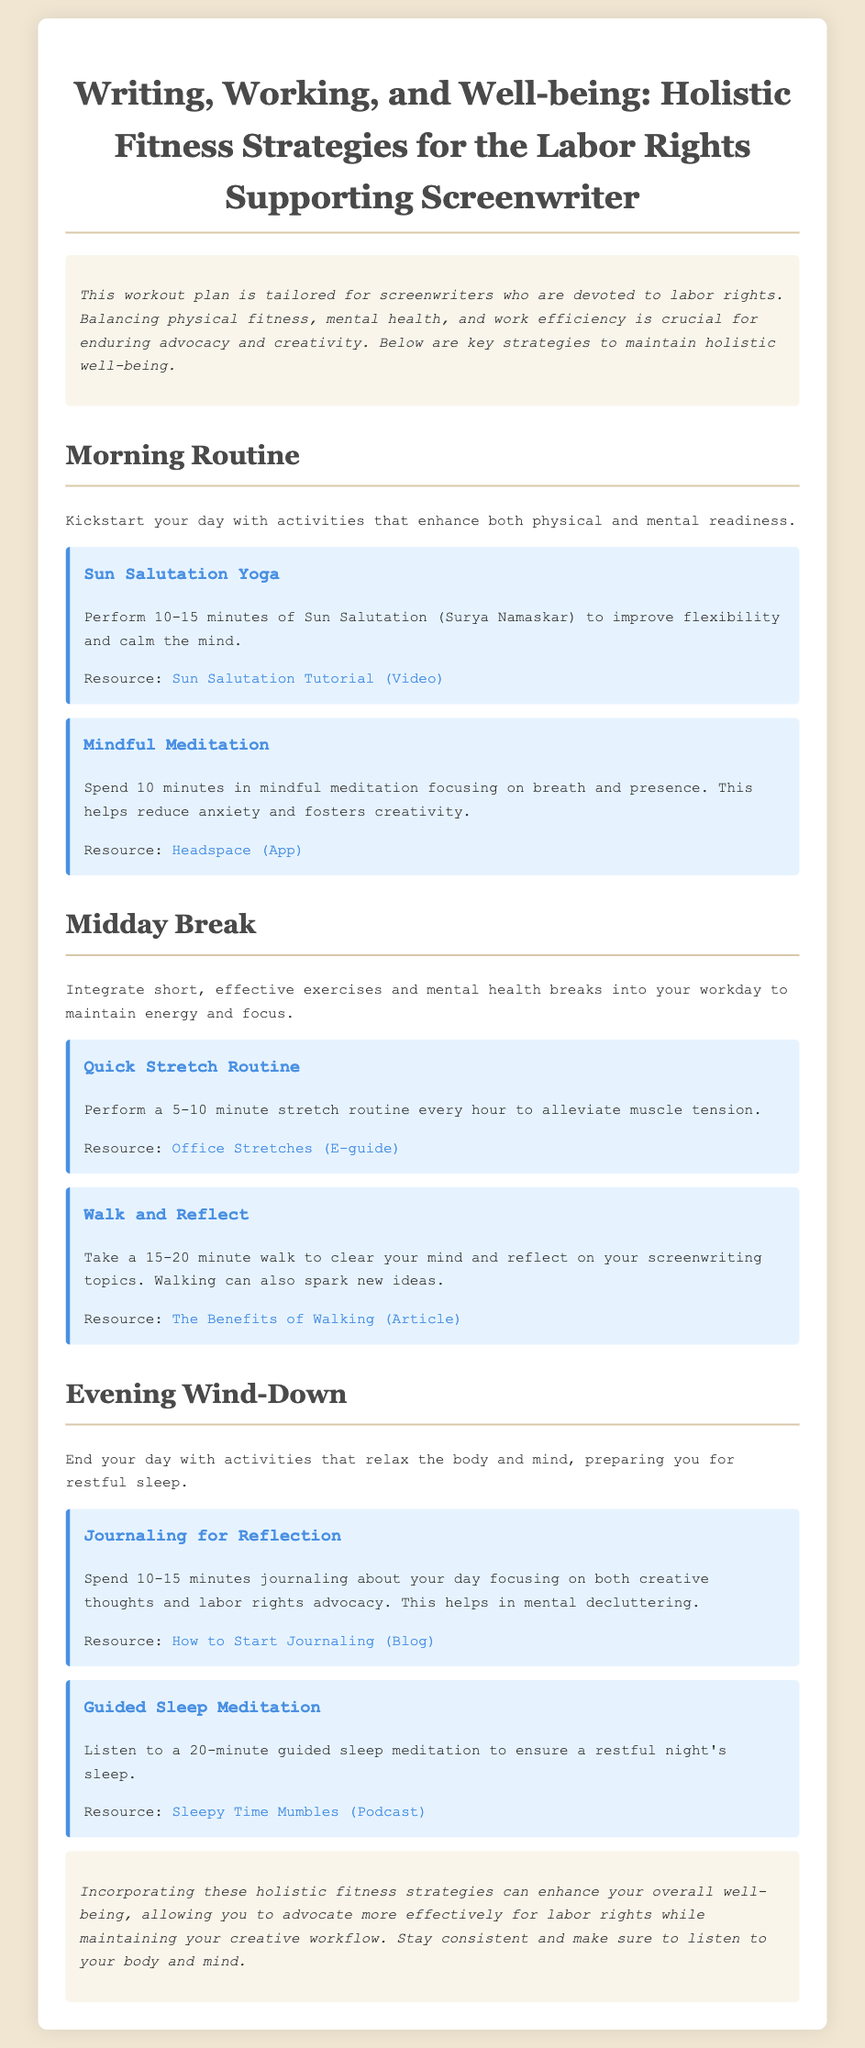what is the title of the document? The title is specified at the top of the document, providing a clear indication of the main theme and purpose.
Answer: Writing, Working, and Well-being: Holistic Fitness Strategies for the Labor Rights Supporting Screenwriter how long should the Sun Salutation Yoga be performed? The document specifies a time range for performing this activity, indicating its duration for effectiveness.
Answer: 10-15 minutes what is one resource linked for Mindful Meditation? The resource for Mindful Meditation is explicitly stated in the document, allowing easy access for users looking to engage in this activity.
Answer: Headspace (App) what is the recommended duration for the Walk and Reflect activity? The document provides a specified time for this activity to highlight its importance in the writing process.
Answer: 15-20 minutes which activity is suggested for the Evening Wind-Down? The document lists specific activities designated for this time of day, focusing on relaxation and reflection.
Answer: Journaling for Reflection how many minutes of journaling is recommended? The document indicates a time frame for this reflective activity, underlining its significance in mental well-being.
Answer: 10-15 minutes what is the benefit of the Quick Stretch Routine? The document outlines the purpose of this activity within the workday, emphasizing its importance for physical health.
Answer: Alleviate muscle tension which activity aids in preparing for restful sleep? The document covers several activities, specifying which one focuses specifically on promoting quality sleep at night.
Answer: Guided Sleep Meditation 